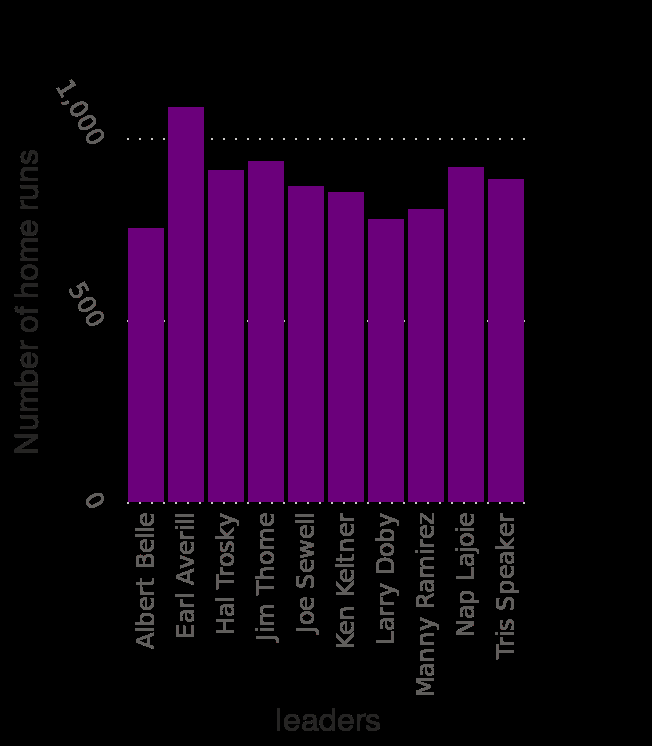<image>
How many players are represented on the x-axis of the bar diagram?  There are multiple players represented on the x-axis of the bar diagram, starting with Albert Belle and ending with an unspecified leader. What does the y-axis represent on the bar diagram? The y-axis on the bar diagram represents the number of home runs. 